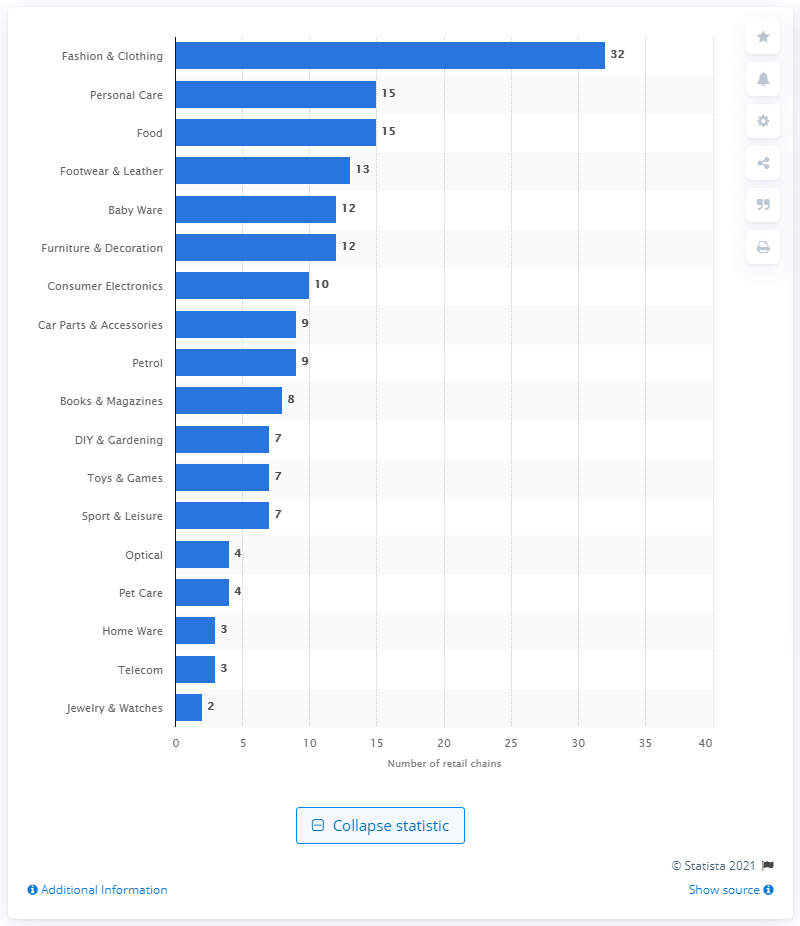Mention a couple of crucial points in this snapshot. There were 32 retail chains in the fashion and clothing industry in Bulgaria in 2020. In the year 2020, there were 15 retail chains operating in the personal care and food sector in Bulgaria. 